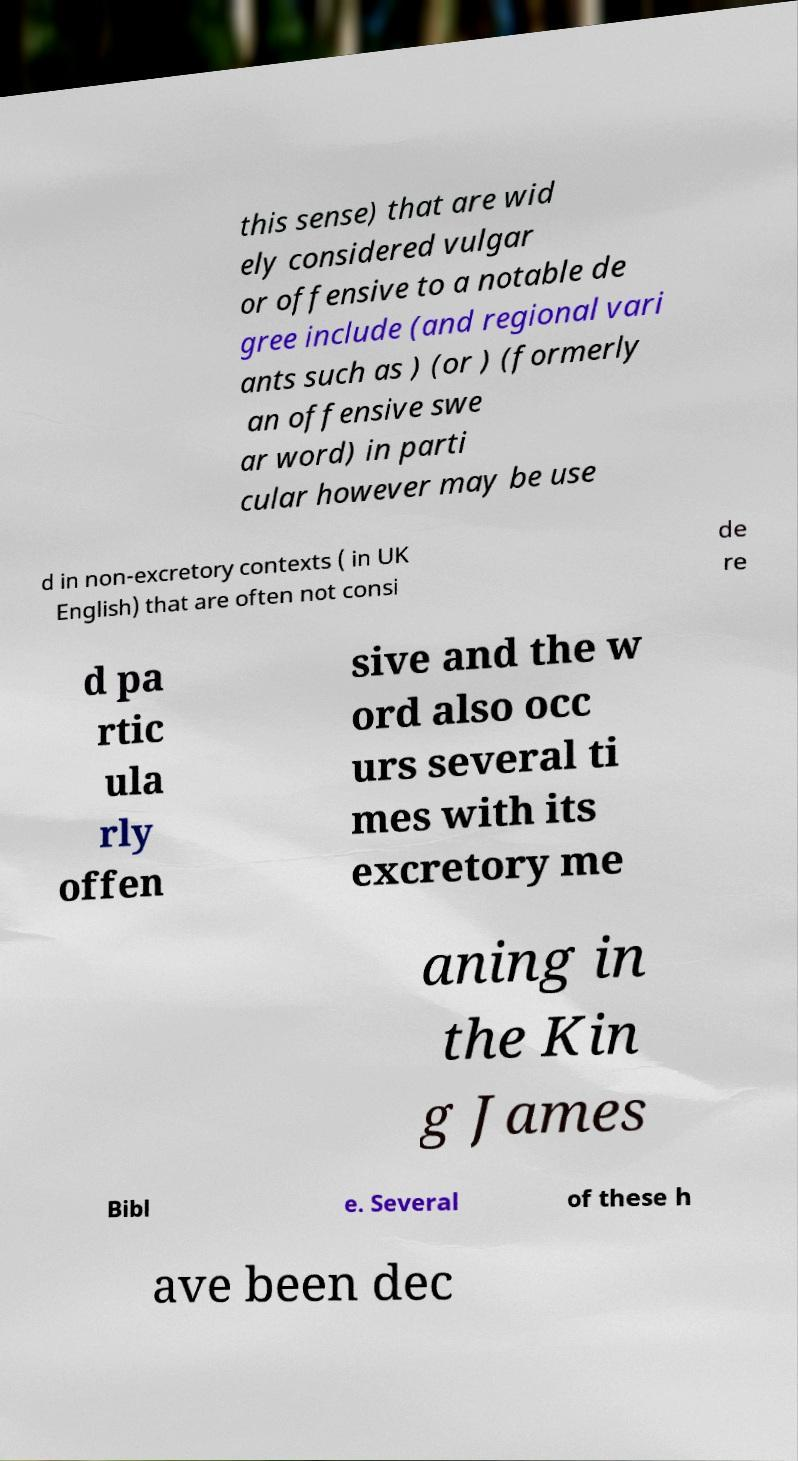Can you accurately transcribe the text from the provided image for me? this sense) that are wid ely considered vulgar or offensive to a notable de gree include (and regional vari ants such as ) (or ) (formerly an offensive swe ar word) in parti cular however may be use d in non-excretory contexts ( in UK English) that are often not consi de re d pa rtic ula rly offen sive and the w ord also occ urs several ti mes with its excretory me aning in the Kin g James Bibl e. Several of these h ave been dec 